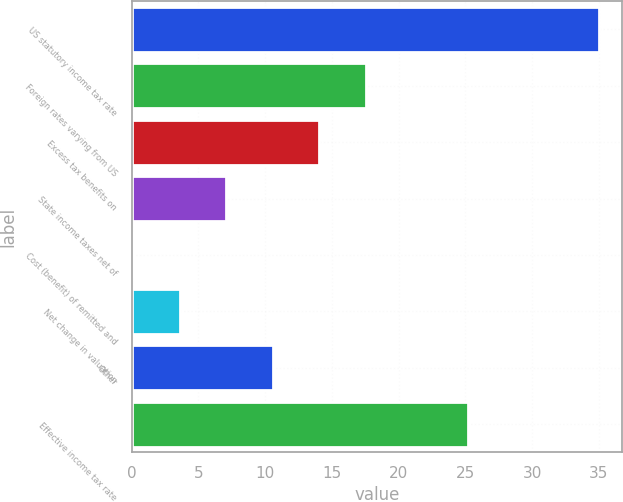Convert chart. <chart><loc_0><loc_0><loc_500><loc_500><bar_chart><fcel>US statutory income tax rate<fcel>Foreign rates varying from US<fcel>Excess tax benefits on<fcel>State income taxes net of<fcel>Cost (benefit) of remitted and<fcel>Net change in valuation<fcel>Other<fcel>Effective income tax rate<nl><fcel>35<fcel>17.55<fcel>14.06<fcel>7.08<fcel>0.1<fcel>3.59<fcel>10.57<fcel>25.2<nl></chart> 